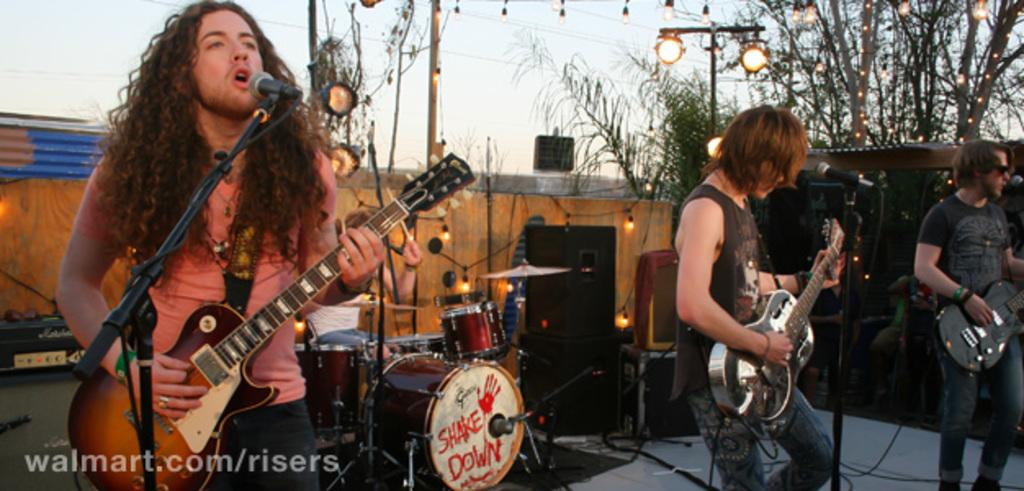How many people are in the image? There are three people in the image. What are the people doing in the image? The people are standing and playing musical instruments. Can you describe any equipment related to their performance? Yes, there is a microphone and a stand in the image. What type of pest can be seen crawling on the tramp in the image? There is no tramp or pest present in the image. 